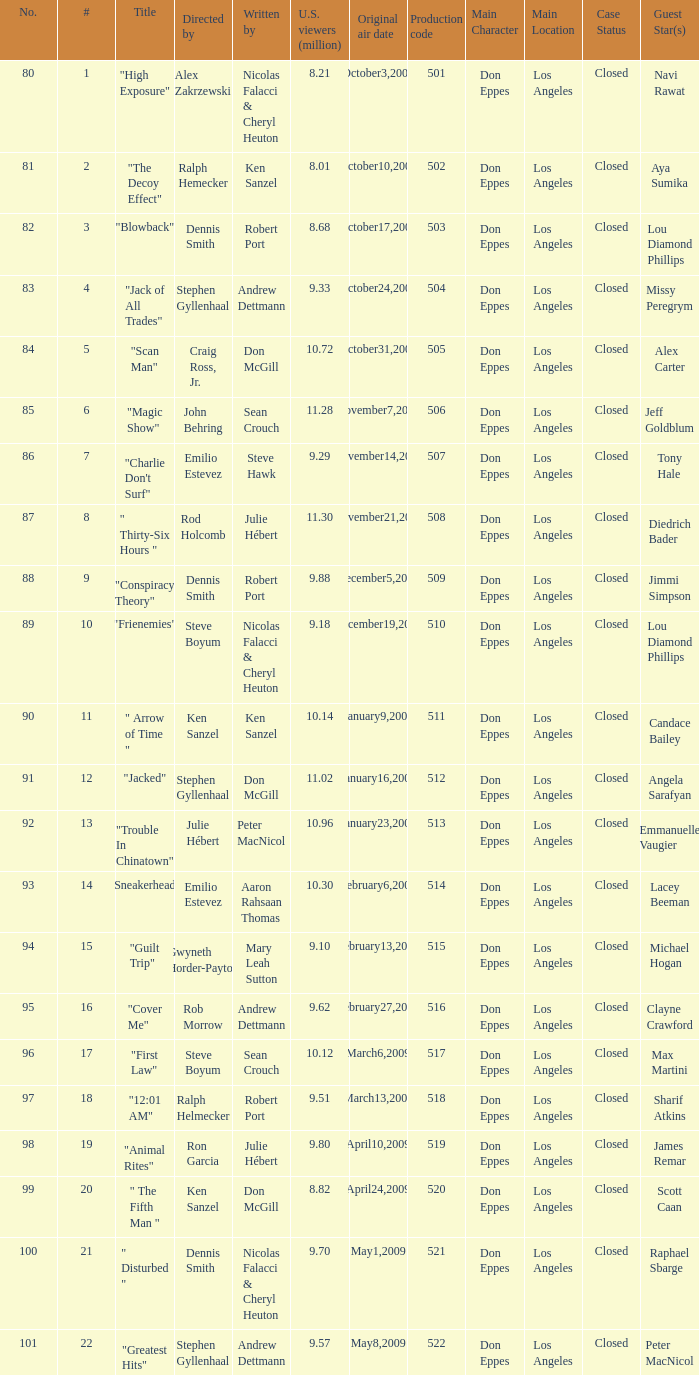What is the production code for the episode that had 9.18 million viewers (U.S.)? 510.0. 